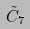Convert formula to latex. <formula><loc_0><loc_0><loc_500><loc_500>\tilde { C } _ { 7 }</formula> 